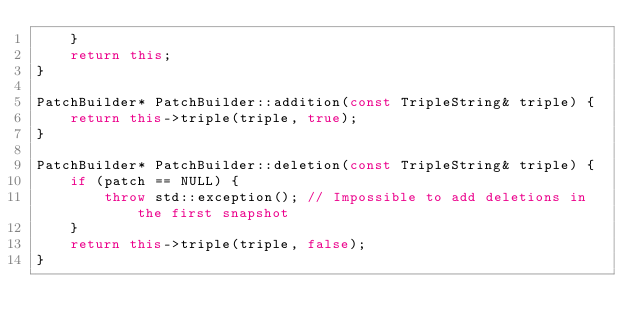Convert code to text. <code><loc_0><loc_0><loc_500><loc_500><_C++_>    }
    return this;
}

PatchBuilder* PatchBuilder::addition(const TripleString& triple) {
    return this->triple(triple, true);
}

PatchBuilder* PatchBuilder::deletion(const TripleString& triple) {
    if (patch == NULL) {
        throw std::exception(); // Impossible to add deletions in the first snapshot
    }
    return this->triple(triple, false);
}
</code> 